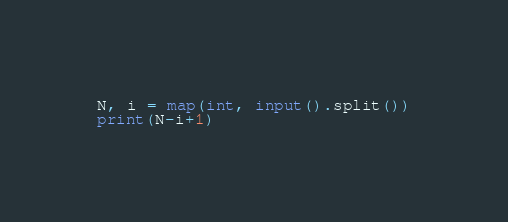Convert code to text. <code><loc_0><loc_0><loc_500><loc_500><_Python_>N, i = map(int, input().split())
print(N-i+1)</code> 